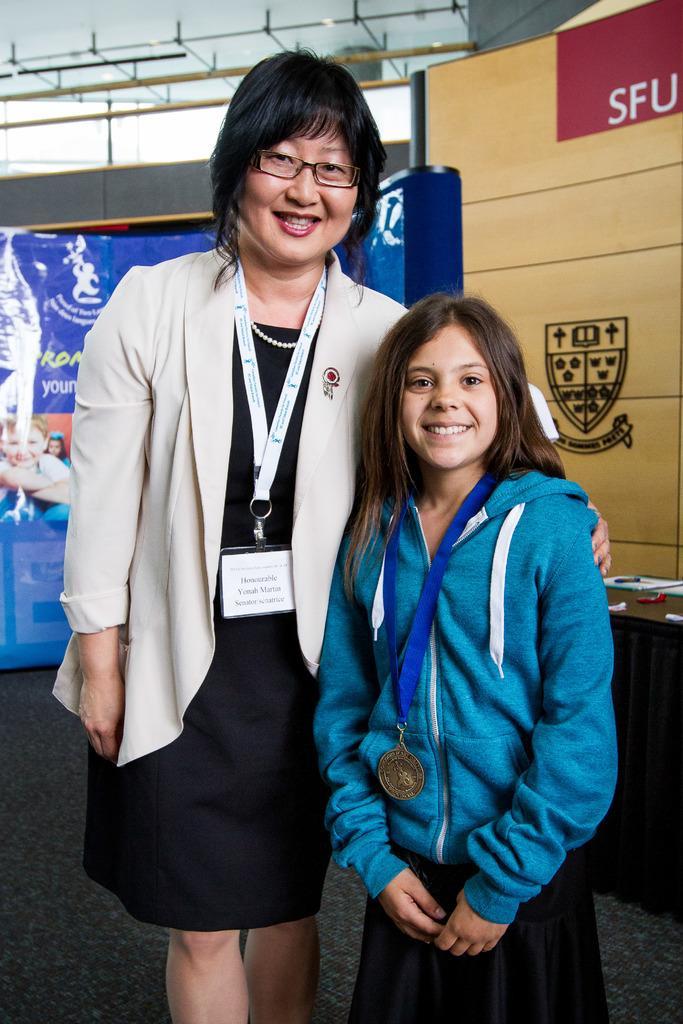Please provide a concise description of this image. In this image we can see two persons in which one of them is wearing a tag and the other is wearing a medal, there we can also see some banners, few lights hanging from the roof. 